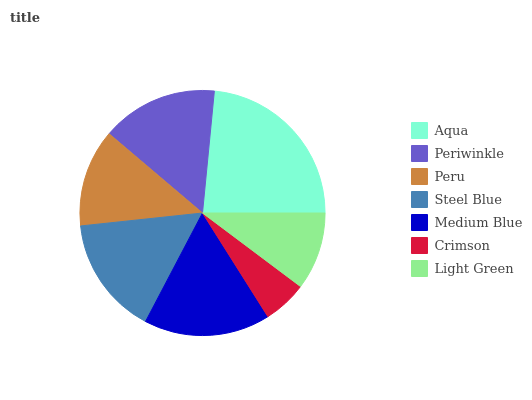Is Crimson the minimum?
Answer yes or no. Yes. Is Aqua the maximum?
Answer yes or no. Yes. Is Periwinkle the minimum?
Answer yes or no. No. Is Periwinkle the maximum?
Answer yes or no. No. Is Aqua greater than Periwinkle?
Answer yes or no. Yes. Is Periwinkle less than Aqua?
Answer yes or no. Yes. Is Periwinkle greater than Aqua?
Answer yes or no. No. Is Aqua less than Periwinkle?
Answer yes or no. No. Is Periwinkle the high median?
Answer yes or no. Yes. Is Periwinkle the low median?
Answer yes or no. Yes. Is Aqua the high median?
Answer yes or no. No. Is Peru the low median?
Answer yes or no. No. 